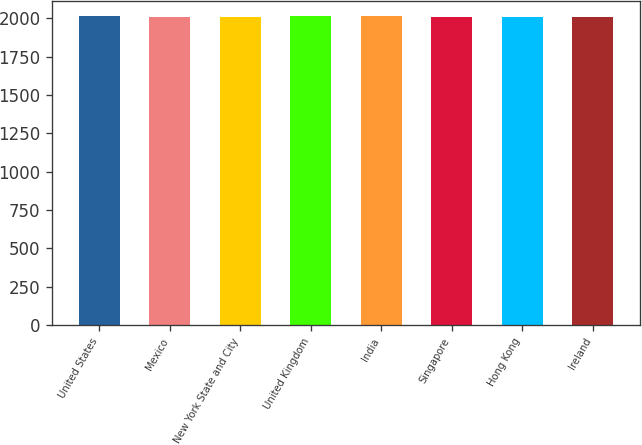Convert chart. <chart><loc_0><loc_0><loc_500><loc_500><bar_chart><fcel>United States<fcel>Mexico<fcel>New York State and City<fcel>United Kingdom<fcel>India<fcel>Singapore<fcel>Hong Kong<fcel>Ireland<nl><fcel>2014<fcel>2009<fcel>2006<fcel>2014.8<fcel>2013<fcel>2011<fcel>2010<fcel>2012<nl></chart> 